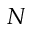Convert formula to latex. <formula><loc_0><loc_0><loc_500><loc_500>N</formula> 